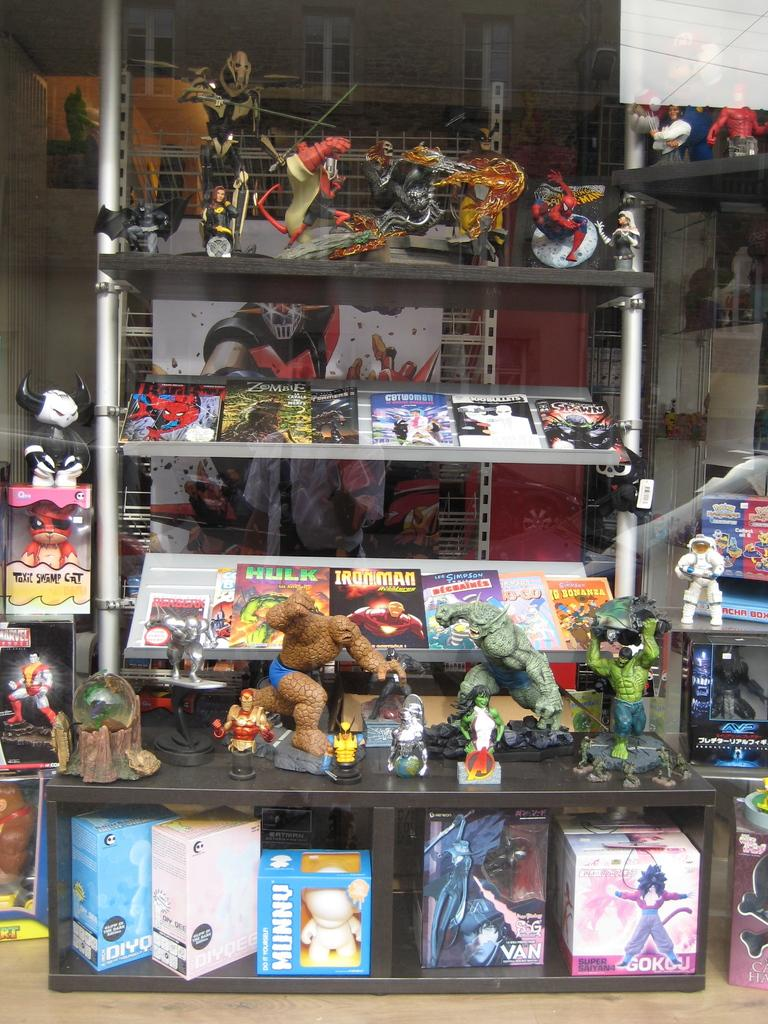<image>
Present a compact description of the photo's key features. A variety of comics memorabilia is displayed on several shelves with a copy of iron man visible on the bottom shelf behind the statues. 